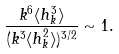<formula> <loc_0><loc_0><loc_500><loc_500>\frac { k ^ { 6 } \langle h _ { k } ^ { 3 } \rangle } { ( k ^ { 3 } \langle h _ { k } ^ { 2 } \rangle ) ^ { 3 / 2 } } \sim 1 .</formula> 